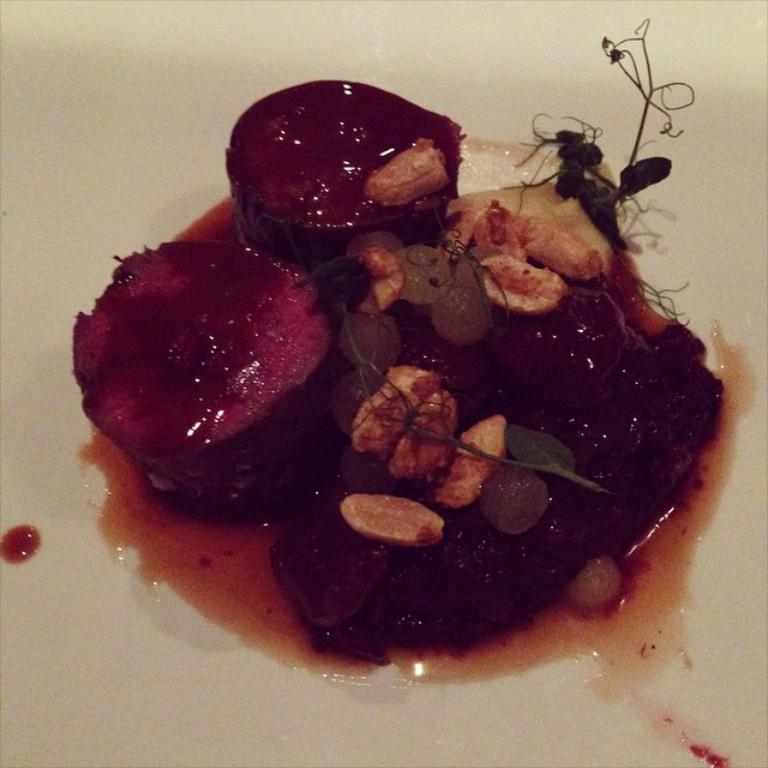What is on the plate that is visible in the image? There is a plate containing food in the image. What channel is the button controlling in the image? There is no button or channel present in the image; it only features a plate containing food. 